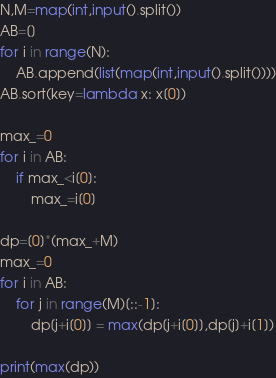<code> <loc_0><loc_0><loc_500><loc_500><_Python_>N,M=map(int,input().split())
AB=[]
for i in range(N):
    AB.append(list(map(int,input().split())))
AB.sort(key=lambda x: x[0])

max_=0
for i in AB:
    if max_<i[0]:
        max_=i[0]

dp=[0]*(max_+M)
max_=0
for i in AB:
    for j in range(M)[::-1]:
        dp[j+i[0]] = max(dp[j+i[0]],dp[j]+i[1])
        
print(max(dp))</code> 